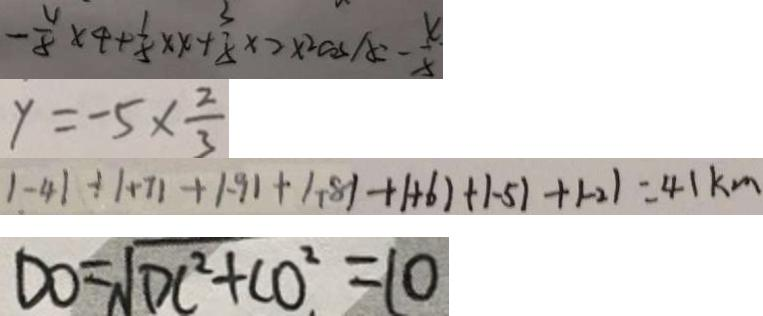Convert formula to latex. <formula><loc_0><loc_0><loc_500><loc_500>- \frac { 4 } { 8 } \times 4 + \frac { 1 } { 8 } \times x + \frac { 3 } { 8 } \times 2 \times 2 \cos A = - \frac { 4 . } { 8 } 
 y = - 5 \times \frac { 2 } { 3 } 
 1 - 4 1 + 1 + 7 1 + 1 . 9 1 + 1 . 8 1 + 1 + 6 1 + 1 - 5 1 + 1 - 2 1 = 4 1 k m 
 D O = \sqrt { D C ^ { 2 } + C O ^ { 2 } } = 1 0</formula> 